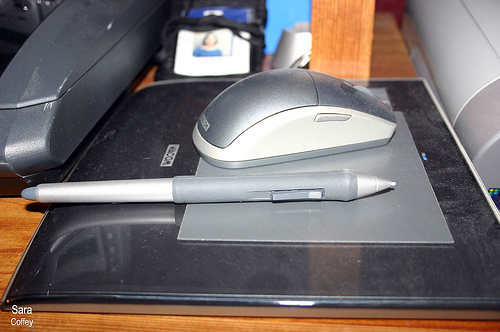<image>
Is the mouse in front of the pen? No. The mouse is not in front of the pen. The spatial positioning shows a different relationship between these objects. 